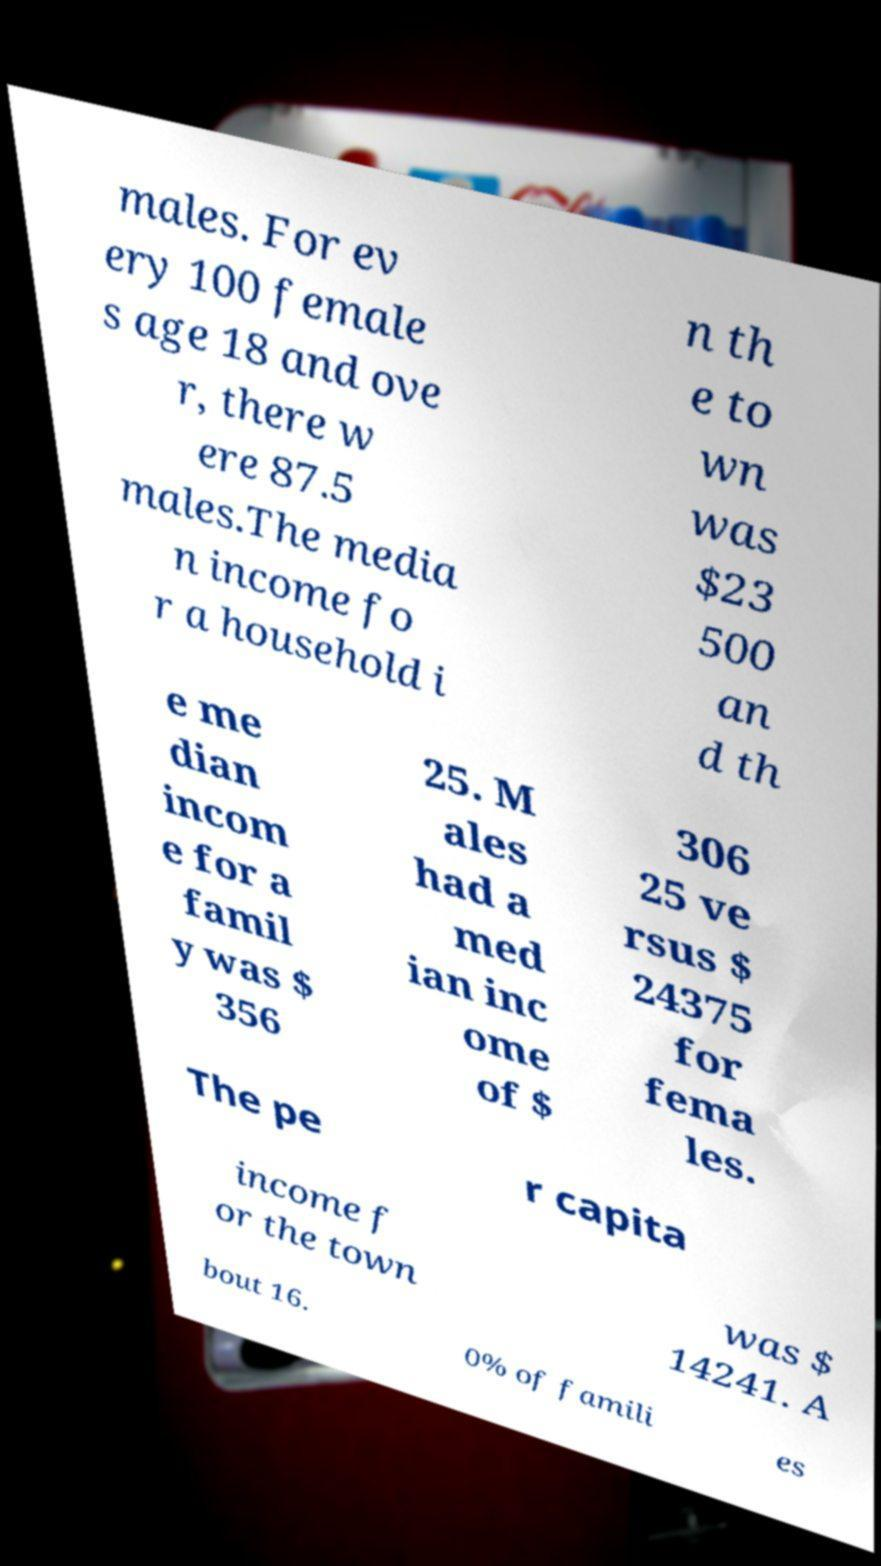Can you read and provide the text displayed in the image?This photo seems to have some interesting text. Can you extract and type it out for me? males. For ev ery 100 female s age 18 and ove r, there w ere 87.5 males.The media n income fo r a household i n th e to wn was $23 500 an d th e me dian incom e for a famil y was $ 356 25. M ales had a med ian inc ome of $ 306 25 ve rsus $ 24375 for fema les. The pe r capita income f or the town was $ 14241. A bout 16. 0% of famili es 